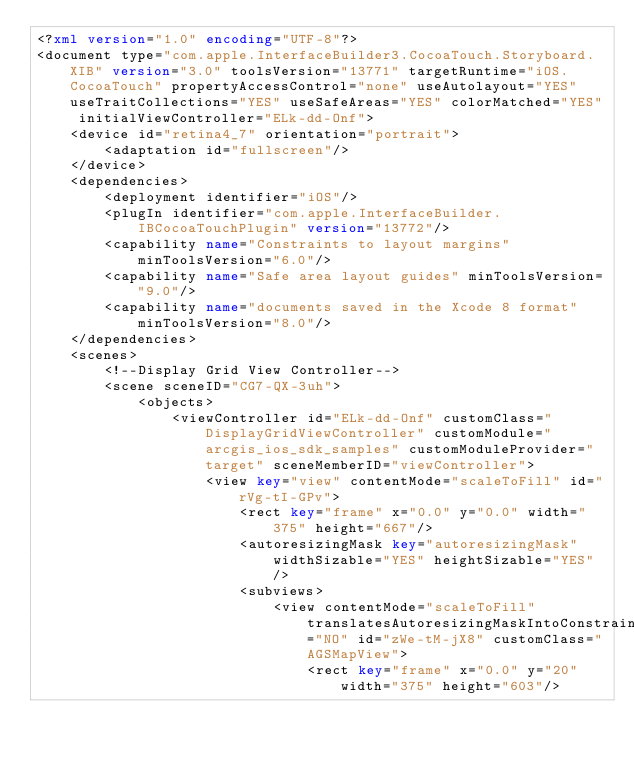<code> <loc_0><loc_0><loc_500><loc_500><_XML_><?xml version="1.0" encoding="UTF-8"?>
<document type="com.apple.InterfaceBuilder3.CocoaTouch.Storyboard.XIB" version="3.0" toolsVersion="13771" targetRuntime="iOS.CocoaTouch" propertyAccessControl="none" useAutolayout="YES" useTraitCollections="YES" useSafeAreas="YES" colorMatched="YES" initialViewController="ELk-dd-Onf">
    <device id="retina4_7" orientation="portrait">
        <adaptation id="fullscreen"/>
    </device>
    <dependencies>
        <deployment identifier="iOS"/>
        <plugIn identifier="com.apple.InterfaceBuilder.IBCocoaTouchPlugin" version="13772"/>
        <capability name="Constraints to layout margins" minToolsVersion="6.0"/>
        <capability name="Safe area layout guides" minToolsVersion="9.0"/>
        <capability name="documents saved in the Xcode 8 format" minToolsVersion="8.0"/>
    </dependencies>
    <scenes>
        <!--Display Grid View Controller-->
        <scene sceneID="CG7-QX-3uh">
            <objects>
                <viewController id="ELk-dd-Onf" customClass="DisplayGridViewController" customModule="arcgis_ios_sdk_samples" customModuleProvider="target" sceneMemberID="viewController">
                    <view key="view" contentMode="scaleToFill" id="rVg-tI-GPv">
                        <rect key="frame" x="0.0" y="0.0" width="375" height="667"/>
                        <autoresizingMask key="autoresizingMask" widthSizable="YES" heightSizable="YES"/>
                        <subviews>
                            <view contentMode="scaleToFill" translatesAutoresizingMaskIntoConstraints="NO" id="zWe-tM-jX8" customClass="AGSMapView">
                                <rect key="frame" x="0.0" y="20" width="375" height="603"/></code> 